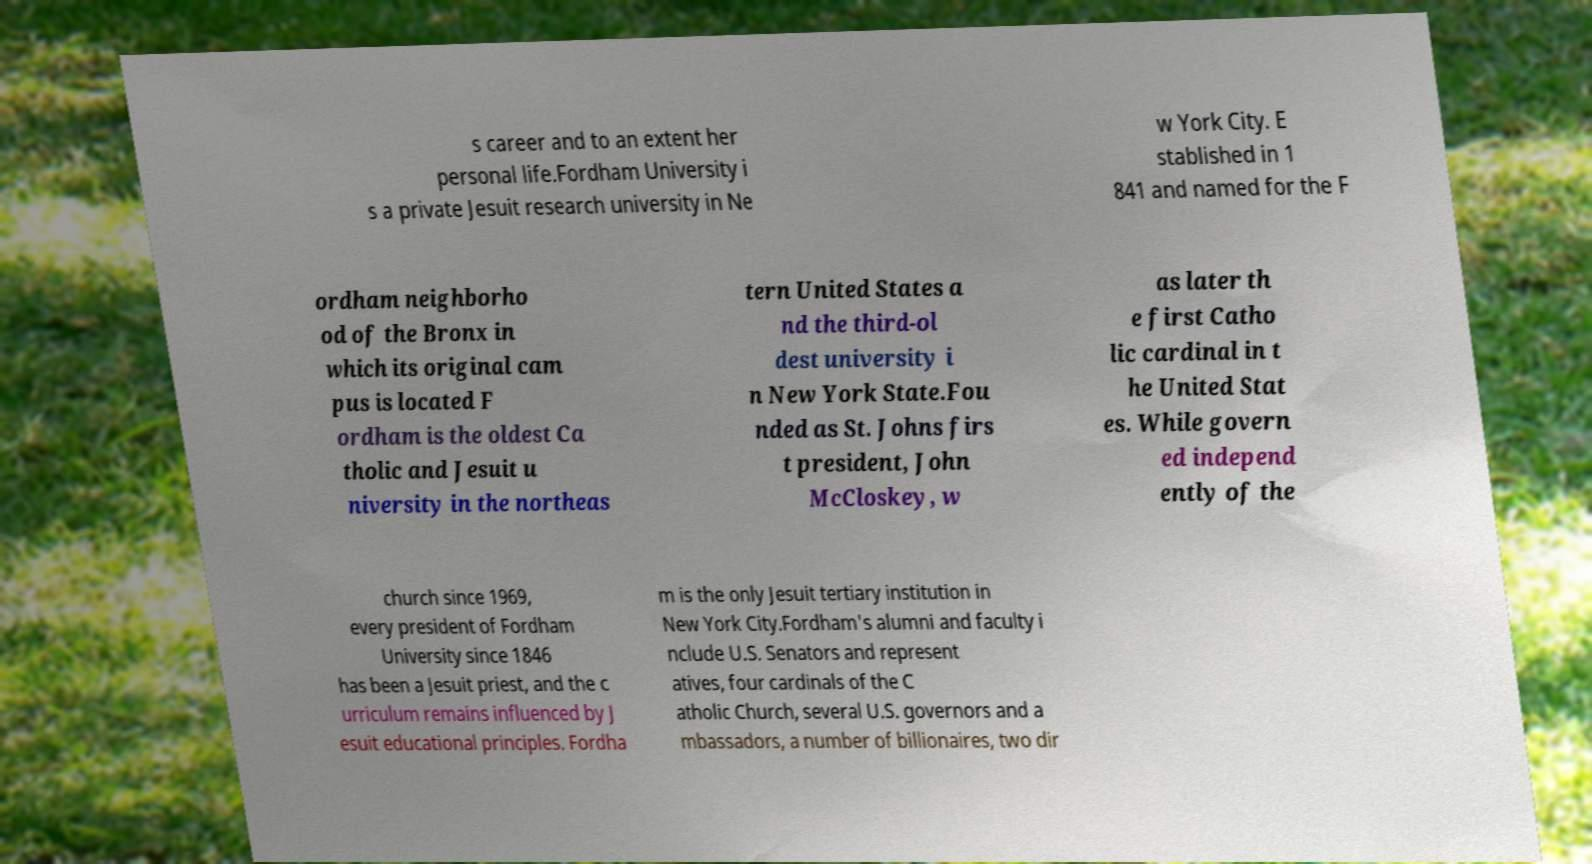Please identify and transcribe the text found in this image. s career and to an extent her personal life.Fordham University i s a private Jesuit research university in Ne w York City. E stablished in 1 841 and named for the F ordham neighborho od of the Bronx in which its original cam pus is located F ordham is the oldest Ca tholic and Jesuit u niversity in the northeas tern United States a nd the third-ol dest university i n New York State.Fou nded as St. Johns firs t president, John McCloskey, w as later th e first Catho lic cardinal in t he United Stat es. While govern ed independ ently of the church since 1969, every president of Fordham University since 1846 has been a Jesuit priest, and the c urriculum remains influenced by J esuit educational principles. Fordha m is the only Jesuit tertiary institution in New York City.Fordham's alumni and faculty i nclude U.S. Senators and represent atives, four cardinals of the C atholic Church, several U.S. governors and a mbassadors, a number of billionaires, two dir 